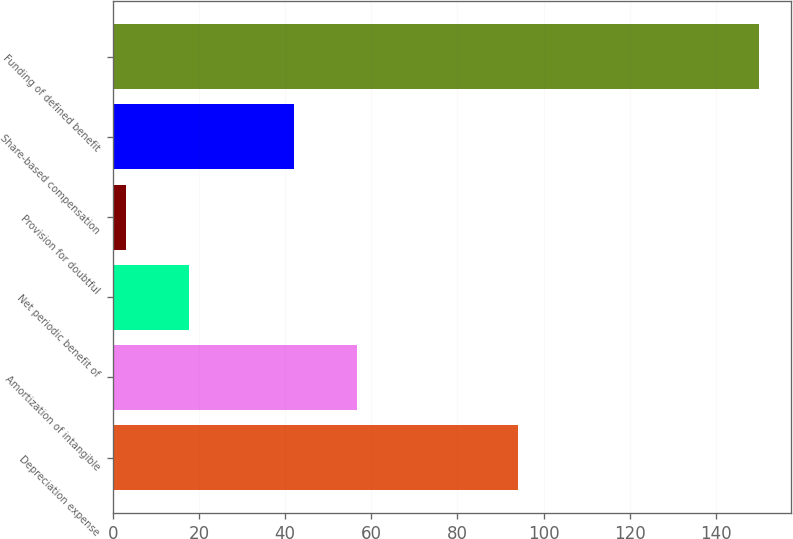Convert chart to OTSL. <chart><loc_0><loc_0><loc_500><loc_500><bar_chart><fcel>Depreciation expense<fcel>Amortization of intangible<fcel>Net periodic benefit of<fcel>Provision for doubtful<fcel>Share-based compensation<fcel>Funding of defined benefit<nl><fcel>94<fcel>56.7<fcel>17.7<fcel>3<fcel>42<fcel>150<nl></chart> 